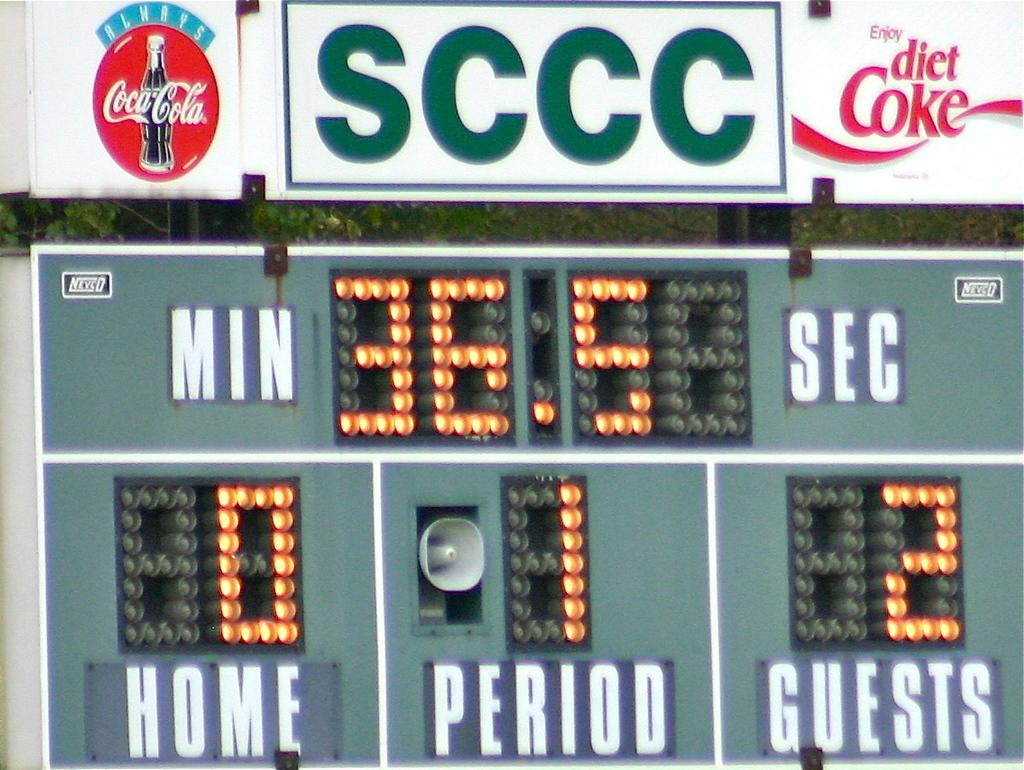<image>
Offer a succinct explanation of the picture presented. Scoreboard for a soccer game showing coca cola ads and time left in match. 